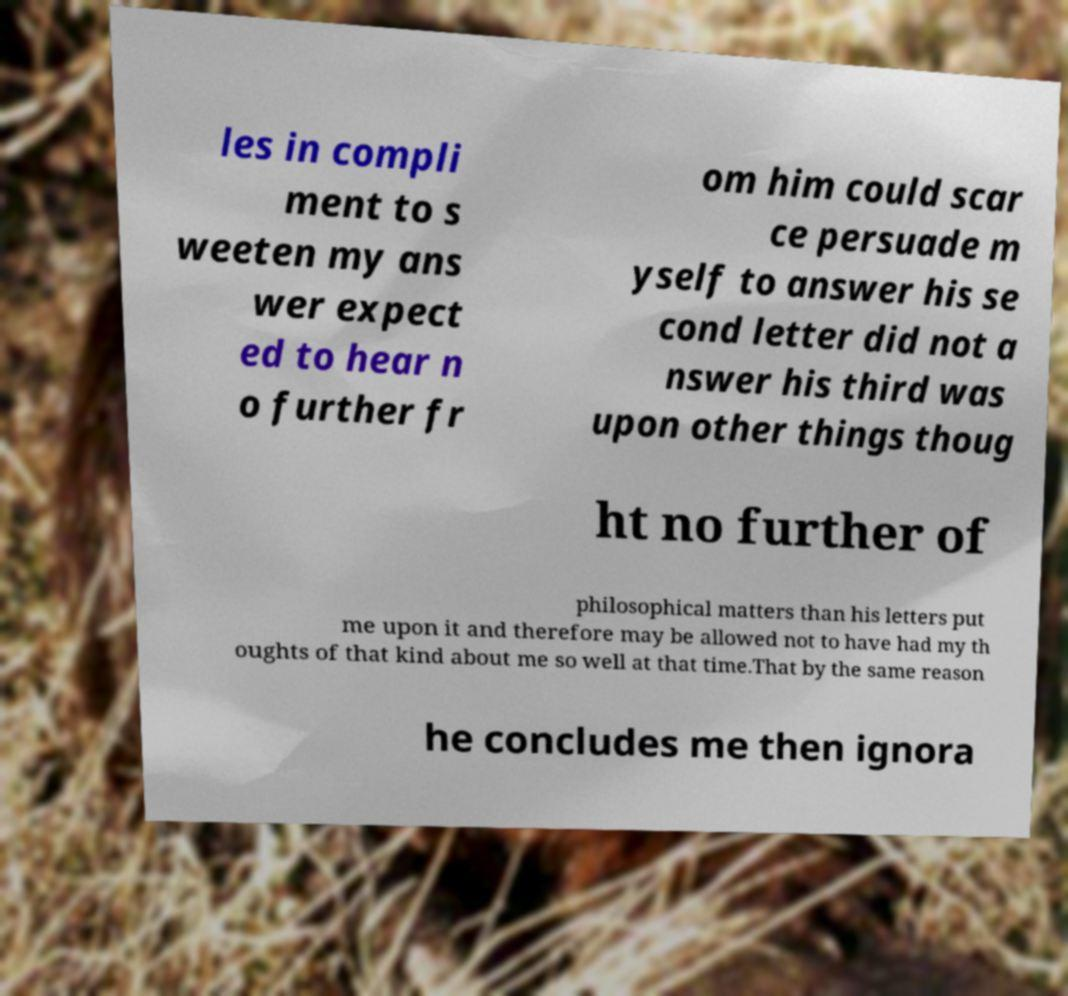Could you assist in decoding the text presented in this image and type it out clearly? les in compli ment to s weeten my ans wer expect ed to hear n o further fr om him could scar ce persuade m yself to answer his se cond letter did not a nswer his third was upon other things thoug ht no further of philosophical matters than his letters put me upon it and therefore may be allowed not to have had my th oughts of that kind about me so well at that time.That by the same reason he concludes me then ignora 